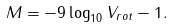Convert formula to latex. <formula><loc_0><loc_0><loc_500><loc_500>M = - 9 \log _ { 1 0 } V _ { r o t } - 1 .</formula> 